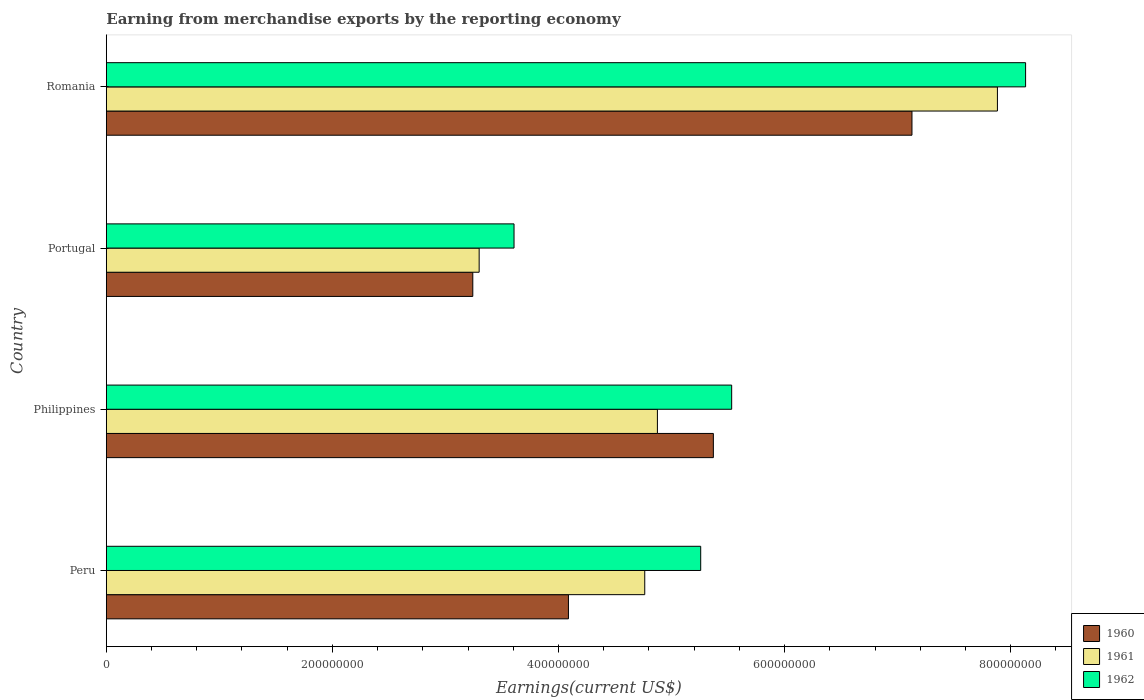How many different coloured bars are there?
Your response must be concise. 3. Are the number of bars on each tick of the Y-axis equal?
Offer a very short reply. Yes. How many bars are there on the 2nd tick from the top?
Keep it short and to the point. 3. How many bars are there on the 1st tick from the bottom?
Your response must be concise. 3. What is the label of the 1st group of bars from the top?
Make the answer very short. Romania. In how many cases, is the number of bars for a given country not equal to the number of legend labels?
Your answer should be compact. 0. What is the amount earned from merchandise exports in 1960 in Portugal?
Provide a succinct answer. 3.24e+08. Across all countries, what is the maximum amount earned from merchandise exports in 1962?
Your response must be concise. 8.13e+08. Across all countries, what is the minimum amount earned from merchandise exports in 1961?
Ensure brevity in your answer.  3.30e+08. In which country was the amount earned from merchandise exports in 1960 maximum?
Keep it short and to the point. Romania. What is the total amount earned from merchandise exports in 1961 in the graph?
Offer a very short reply. 2.08e+09. What is the difference between the amount earned from merchandise exports in 1961 in Portugal and that in Romania?
Provide a short and direct response. -4.58e+08. What is the difference between the amount earned from merchandise exports in 1961 in Romania and the amount earned from merchandise exports in 1960 in Philippines?
Offer a terse response. 2.51e+08. What is the average amount earned from merchandise exports in 1961 per country?
Your answer should be compact. 5.20e+08. What is the difference between the amount earned from merchandise exports in 1962 and amount earned from merchandise exports in 1960 in Portugal?
Keep it short and to the point. 3.65e+07. In how many countries, is the amount earned from merchandise exports in 1960 greater than 400000000 US$?
Provide a succinct answer. 3. What is the ratio of the amount earned from merchandise exports in 1962 in Philippines to that in Romania?
Make the answer very short. 0.68. Is the difference between the amount earned from merchandise exports in 1962 in Peru and Portugal greater than the difference between the amount earned from merchandise exports in 1960 in Peru and Portugal?
Give a very brief answer. Yes. What is the difference between the highest and the second highest amount earned from merchandise exports in 1960?
Offer a very short reply. 1.76e+08. What is the difference between the highest and the lowest amount earned from merchandise exports in 1960?
Ensure brevity in your answer.  3.89e+08. What does the 3rd bar from the bottom in Peru represents?
Your answer should be compact. 1962. Is it the case that in every country, the sum of the amount earned from merchandise exports in 1960 and amount earned from merchandise exports in 1961 is greater than the amount earned from merchandise exports in 1962?
Keep it short and to the point. Yes. How many bars are there?
Offer a very short reply. 12. Are all the bars in the graph horizontal?
Make the answer very short. Yes. Does the graph contain grids?
Your answer should be compact. No. Where does the legend appear in the graph?
Provide a succinct answer. Bottom right. How are the legend labels stacked?
Your answer should be compact. Vertical. What is the title of the graph?
Your answer should be very brief. Earning from merchandise exports by the reporting economy. Does "2008" appear as one of the legend labels in the graph?
Give a very brief answer. No. What is the label or title of the X-axis?
Offer a very short reply. Earnings(current US$). What is the Earnings(current US$) in 1960 in Peru?
Provide a short and direct response. 4.09e+08. What is the Earnings(current US$) in 1961 in Peru?
Offer a very short reply. 4.76e+08. What is the Earnings(current US$) in 1962 in Peru?
Your answer should be compact. 5.26e+08. What is the Earnings(current US$) in 1960 in Philippines?
Your answer should be compact. 5.37e+08. What is the Earnings(current US$) in 1961 in Philippines?
Offer a very short reply. 4.88e+08. What is the Earnings(current US$) in 1962 in Philippines?
Provide a short and direct response. 5.53e+08. What is the Earnings(current US$) in 1960 in Portugal?
Provide a short and direct response. 3.24e+08. What is the Earnings(current US$) in 1961 in Portugal?
Offer a terse response. 3.30e+08. What is the Earnings(current US$) in 1962 in Portugal?
Your response must be concise. 3.61e+08. What is the Earnings(current US$) in 1960 in Romania?
Offer a terse response. 7.13e+08. What is the Earnings(current US$) of 1961 in Romania?
Make the answer very short. 7.88e+08. What is the Earnings(current US$) in 1962 in Romania?
Ensure brevity in your answer.  8.13e+08. Across all countries, what is the maximum Earnings(current US$) of 1960?
Your response must be concise. 7.13e+08. Across all countries, what is the maximum Earnings(current US$) in 1961?
Your answer should be compact. 7.88e+08. Across all countries, what is the maximum Earnings(current US$) in 1962?
Provide a short and direct response. 8.13e+08. Across all countries, what is the minimum Earnings(current US$) in 1960?
Provide a succinct answer. 3.24e+08. Across all countries, what is the minimum Earnings(current US$) of 1961?
Your answer should be very brief. 3.30e+08. Across all countries, what is the minimum Earnings(current US$) of 1962?
Your response must be concise. 3.61e+08. What is the total Earnings(current US$) of 1960 in the graph?
Your answer should be compact. 1.98e+09. What is the total Earnings(current US$) of 1961 in the graph?
Offer a very short reply. 2.08e+09. What is the total Earnings(current US$) of 1962 in the graph?
Ensure brevity in your answer.  2.25e+09. What is the difference between the Earnings(current US$) of 1960 in Peru and that in Philippines?
Ensure brevity in your answer.  -1.28e+08. What is the difference between the Earnings(current US$) in 1961 in Peru and that in Philippines?
Your response must be concise. -1.12e+07. What is the difference between the Earnings(current US$) in 1962 in Peru and that in Philippines?
Keep it short and to the point. -2.74e+07. What is the difference between the Earnings(current US$) in 1960 in Peru and that in Portugal?
Your response must be concise. 8.46e+07. What is the difference between the Earnings(current US$) of 1961 in Peru and that in Portugal?
Your response must be concise. 1.46e+08. What is the difference between the Earnings(current US$) of 1962 in Peru and that in Portugal?
Give a very brief answer. 1.65e+08. What is the difference between the Earnings(current US$) of 1960 in Peru and that in Romania?
Provide a succinct answer. -3.04e+08. What is the difference between the Earnings(current US$) of 1961 in Peru and that in Romania?
Ensure brevity in your answer.  -3.12e+08. What is the difference between the Earnings(current US$) in 1962 in Peru and that in Romania?
Give a very brief answer. -2.87e+08. What is the difference between the Earnings(current US$) in 1960 in Philippines and that in Portugal?
Keep it short and to the point. 2.13e+08. What is the difference between the Earnings(current US$) of 1961 in Philippines and that in Portugal?
Offer a very short reply. 1.58e+08. What is the difference between the Earnings(current US$) in 1962 in Philippines and that in Portugal?
Give a very brief answer. 1.93e+08. What is the difference between the Earnings(current US$) in 1960 in Philippines and that in Romania?
Your response must be concise. -1.76e+08. What is the difference between the Earnings(current US$) of 1961 in Philippines and that in Romania?
Ensure brevity in your answer.  -3.01e+08. What is the difference between the Earnings(current US$) in 1962 in Philippines and that in Romania?
Your answer should be compact. -2.60e+08. What is the difference between the Earnings(current US$) in 1960 in Portugal and that in Romania?
Keep it short and to the point. -3.89e+08. What is the difference between the Earnings(current US$) of 1961 in Portugal and that in Romania?
Ensure brevity in your answer.  -4.58e+08. What is the difference between the Earnings(current US$) of 1962 in Portugal and that in Romania?
Ensure brevity in your answer.  -4.53e+08. What is the difference between the Earnings(current US$) of 1960 in Peru and the Earnings(current US$) of 1961 in Philippines?
Your response must be concise. -7.87e+07. What is the difference between the Earnings(current US$) of 1960 in Peru and the Earnings(current US$) of 1962 in Philippines?
Your answer should be compact. -1.44e+08. What is the difference between the Earnings(current US$) in 1961 in Peru and the Earnings(current US$) in 1962 in Philippines?
Give a very brief answer. -7.69e+07. What is the difference between the Earnings(current US$) in 1960 in Peru and the Earnings(current US$) in 1961 in Portugal?
Provide a short and direct response. 7.90e+07. What is the difference between the Earnings(current US$) of 1960 in Peru and the Earnings(current US$) of 1962 in Portugal?
Offer a very short reply. 4.81e+07. What is the difference between the Earnings(current US$) in 1961 in Peru and the Earnings(current US$) in 1962 in Portugal?
Your response must be concise. 1.16e+08. What is the difference between the Earnings(current US$) of 1960 in Peru and the Earnings(current US$) of 1961 in Romania?
Offer a very short reply. -3.79e+08. What is the difference between the Earnings(current US$) in 1960 in Peru and the Earnings(current US$) in 1962 in Romania?
Offer a terse response. -4.04e+08. What is the difference between the Earnings(current US$) of 1961 in Peru and the Earnings(current US$) of 1962 in Romania?
Your response must be concise. -3.37e+08. What is the difference between the Earnings(current US$) in 1960 in Philippines and the Earnings(current US$) in 1961 in Portugal?
Ensure brevity in your answer.  2.07e+08. What is the difference between the Earnings(current US$) in 1960 in Philippines and the Earnings(current US$) in 1962 in Portugal?
Keep it short and to the point. 1.76e+08. What is the difference between the Earnings(current US$) of 1961 in Philippines and the Earnings(current US$) of 1962 in Portugal?
Provide a short and direct response. 1.27e+08. What is the difference between the Earnings(current US$) in 1960 in Philippines and the Earnings(current US$) in 1961 in Romania?
Provide a short and direct response. -2.51e+08. What is the difference between the Earnings(current US$) in 1960 in Philippines and the Earnings(current US$) in 1962 in Romania?
Your answer should be very brief. -2.76e+08. What is the difference between the Earnings(current US$) of 1961 in Philippines and the Earnings(current US$) of 1962 in Romania?
Ensure brevity in your answer.  -3.26e+08. What is the difference between the Earnings(current US$) of 1960 in Portugal and the Earnings(current US$) of 1961 in Romania?
Your answer should be compact. -4.64e+08. What is the difference between the Earnings(current US$) of 1960 in Portugal and the Earnings(current US$) of 1962 in Romania?
Your answer should be compact. -4.89e+08. What is the difference between the Earnings(current US$) of 1961 in Portugal and the Earnings(current US$) of 1962 in Romania?
Provide a succinct answer. -4.83e+08. What is the average Earnings(current US$) of 1960 per country?
Your answer should be compact. 4.96e+08. What is the average Earnings(current US$) of 1961 per country?
Offer a terse response. 5.20e+08. What is the average Earnings(current US$) of 1962 per country?
Offer a terse response. 5.63e+08. What is the difference between the Earnings(current US$) of 1960 and Earnings(current US$) of 1961 in Peru?
Your answer should be compact. -6.75e+07. What is the difference between the Earnings(current US$) in 1960 and Earnings(current US$) in 1962 in Peru?
Ensure brevity in your answer.  -1.17e+08. What is the difference between the Earnings(current US$) in 1961 and Earnings(current US$) in 1962 in Peru?
Your answer should be compact. -4.95e+07. What is the difference between the Earnings(current US$) of 1960 and Earnings(current US$) of 1961 in Philippines?
Your response must be concise. 4.95e+07. What is the difference between the Earnings(current US$) in 1960 and Earnings(current US$) in 1962 in Philippines?
Your response must be concise. -1.62e+07. What is the difference between the Earnings(current US$) in 1961 and Earnings(current US$) in 1962 in Philippines?
Offer a very short reply. -6.57e+07. What is the difference between the Earnings(current US$) of 1960 and Earnings(current US$) of 1961 in Portugal?
Offer a terse response. -5.62e+06. What is the difference between the Earnings(current US$) of 1960 and Earnings(current US$) of 1962 in Portugal?
Keep it short and to the point. -3.65e+07. What is the difference between the Earnings(current US$) of 1961 and Earnings(current US$) of 1962 in Portugal?
Your response must be concise. -3.09e+07. What is the difference between the Earnings(current US$) in 1960 and Earnings(current US$) in 1961 in Romania?
Give a very brief answer. -7.56e+07. What is the difference between the Earnings(current US$) of 1960 and Earnings(current US$) of 1962 in Romania?
Offer a very short reply. -1.01e+08. What is the difference between the Earnings(current US$) in 1961 and Earnings(current US$) in 1962 in Romania?
Provide a succinct answer. -2.49e+07. What is the ratio of the Earnings(current US$) of 1960 in Peru to that in Philippines?
Your answer should be compact. 0.76. What is the ratio of the Earnings(current US$) in 1962 in Peru to that in Philippines?
Give a very brief answer. 0.95. What is the ratio of the Earnings(current US$) in 1960 in Peru to that in Portugal?
Keep it short and to the point. 1.26. What is the ratio of the Earnings(current US$) of 1961 in Peru to that in Portugal?
Keep it short and to the point. 1.44. What is the ratio of the Earnings(current US$) in 1962 in Peru to that in Portugal?
Your response must be concise. 1.46. What is the ratio of the Earnings(current US$) in 1960 in Peru to that in Romania?
Give a very brief answer. 0.57. What is the ratio of the Earnings(current US$) in 1961 in Peru to that in Romania?
Offer a terse response. 0.6. What is the ratio of the Earnings(current US$) of 1962 in Peru to that in Romania?
Offer a very short reply. 0.65. What is the ratio of the Earnings(current US$) of 1960 in Philippines to that in Portugal?
Ensure brevity in your answer.  1.66. What is the ratio of the Earnings(current US$) of 1961 in Philippines to that in Portugal?
Provide a succinct answer. 1.48. What is the ratio of the Earnings(current US$) of 1962 in Philippines to that in Portugal?
Keep it short and to the point. 1.53. What is the ratio of the Earnings(current US$) in 1960 in Philippines to that in Romania?
Offer a terse response. 0.75. What is the ratio of the Earnings(current US$) of 1961 in Philippines to that in Romania?
Provide a short and direct response. 0.62. What is the ratio of the Earnings(current US$) in 1962 in Philippines to that in Romania?
Provide a short and direct response. 0.68. What is the ratio of the Earnings(current US$) of 1960 in Portugal to that in Romania?
Your response must be concise. 0.45. What is the ratio of the Earnings(current US$) of 1961 in Portugal to that in Romania?
Provide a short and direct response. 0.42. What is the ratio of the Earnings(current US$) of 1962 in Portugal to that in Romania?
Your response must be concise. 0.44. What is the difference between the highest and the second highest Earnings(current US$) of 1960?
Offer a very short reply. 1.76e+08. What is the difference between the highest and the second highest Earnings(current US$) of 1961?
Make the answer very short. 3.01e+08. What is the difference between the highest and the second highest Earnings(current US$) in 1962?
Provide a succinct answer. 2.60e+08. What is the difference between the highest and the lowest Earnings(current US$) in 1960?
Keep it short and to the point. 3.89e+08. What is the difference between the highest and the lowest Earnings(current US$) in 1961?
Your answer should be very brief. 4.58e+08. What is the difference between the highest and the lowest Earnings(current US$) in 1962?
Ensure brevity in your answer.  4.53e+08. 